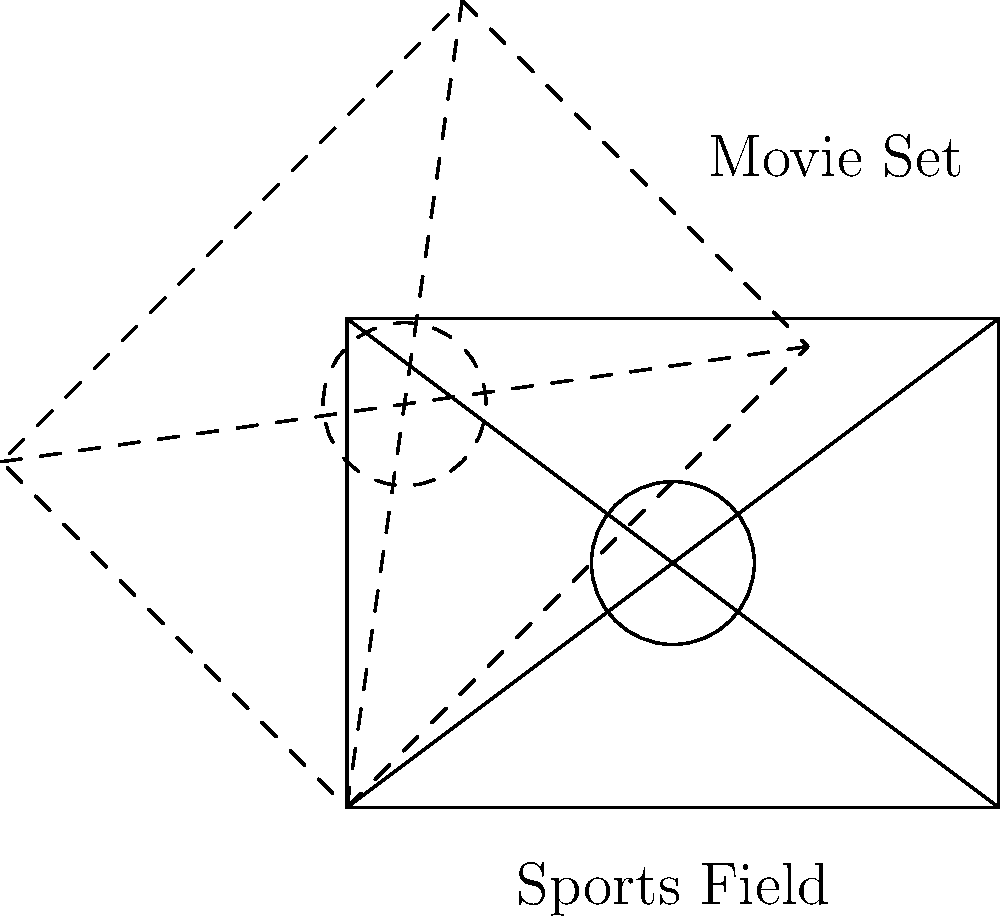As part of your new acting role, you need to understand how the sports field layout will be transformed for the movie set. The diagram shows a rectangular sports field with diagonal lines and a central circle. If the entire field needs to be rotated 45° clockwise to fit the movie set layout, what transformation matrix would you use to achieve this rotation? To rotate a figure by an angle θ clockwise around the origin, we use the rotation matrix:

$$ R = \begin{bmatrix} \cos \theta & \sin \theta \\ -\sin \theta & \cos \theta \end{bmatrix} $$

For a 45° clockwise rotation:

1. θ = 45° = π/4 radians
2. $\cos(45°) = \frac{1}{\sqrt{2}} \approx 0.707$
3. $\sin(45°) = \frac{1}{\sqrt{2}} \approx 0.707$

Substituting these values into the rotation matrix:

$$ R = \begin{bmatrix} \cos(45°) & \sin(45°) \\ -\sin(45°) & \cos(45°) \end{bmatrix} = \begin{bmatrix} \frac{1}{\sqrt{2}} & \frac{1}{\sqrt{2}} \\ -\frac{1}{\sqrt{2}} & \frac{1}{\sqrt{2}} \end{bmatrix} $$

This matrix, when applied to each point of the sports field, will rotate it 45° clockwise to match the movie set layout.
Answer: $\begin{bmatrix} \frac{1}{\sqrt{2}} & \frac{1}{\sqrt{2}} \\ -\frac{1}{\sqrt{2}} & \frac{1}{\sqrt{2}} \end{bmatrix}$ 